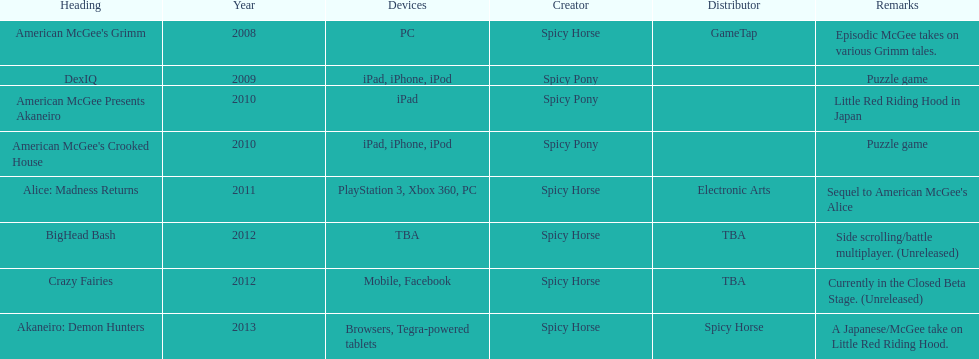Referring to the table, what was spicy horse's last developed title? Akaneiro: Demon Hunters. 